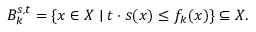Convert formula to latex. <formula><loc_0><loc_0><loc_500><loc_500>B _ { k } ^ { s , t } = \{ x \in X | t \cdot s ( x ) \leq f _ { k } ( x ) \} \subseteq X .</formula> 